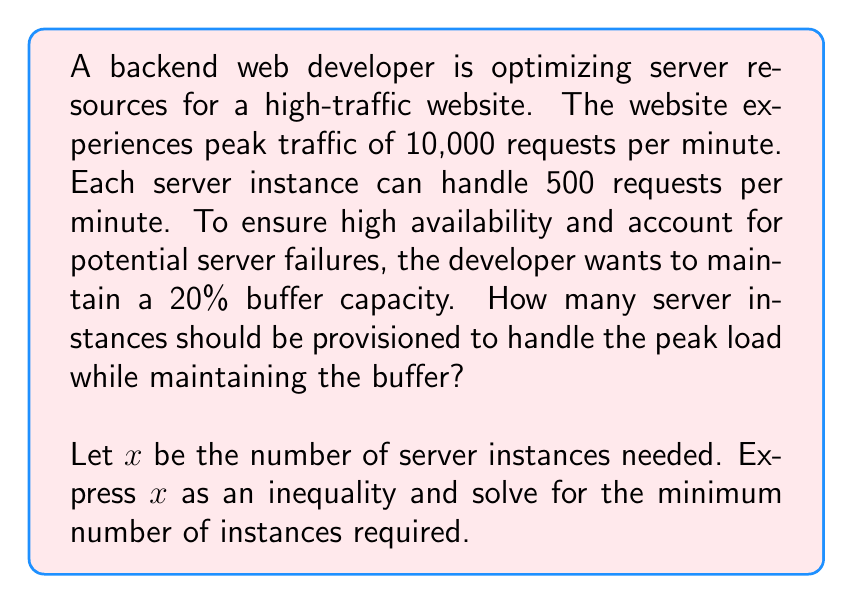Provide a solution to this math problem. To solve this problem, we'll follow these steps:

1. Calculate the total capacity needed:
   Peak traffic = 10,000 requests/minute
   Buffer = 20% = 0.2
   Total capacity needed = Peak traffic * (1 + Buffer)
   $$ 10,000 * (1 + 0.2) = 12,000 \text{ requests/minute} $$

2. Set up the inequality:
   Let $x$ be the number of server instances
   Each server can handle 500 requests/minute
   Total capacity of $x$ servers: $500x$
   
   The inequality is:
   $$ 500x \geq 12,000 $$

3. Solve the inequality:
   $$ x \geq \frac{12,000}{500} = 24 $$

4. Since we can't have a fractional number of servers, we need to round up to the nearest whole number.

Therefore, the minimum number of server instances needed is 24.

This solution ensures that:
- The system can handle the peak traffic of 10,000 requests/minute
- There's a 20% buffer for high availability
- The Apache mod_rewrite module can be configured to distribute traffic across these instances
Answer: The optimal number of server instances needed is 24. 